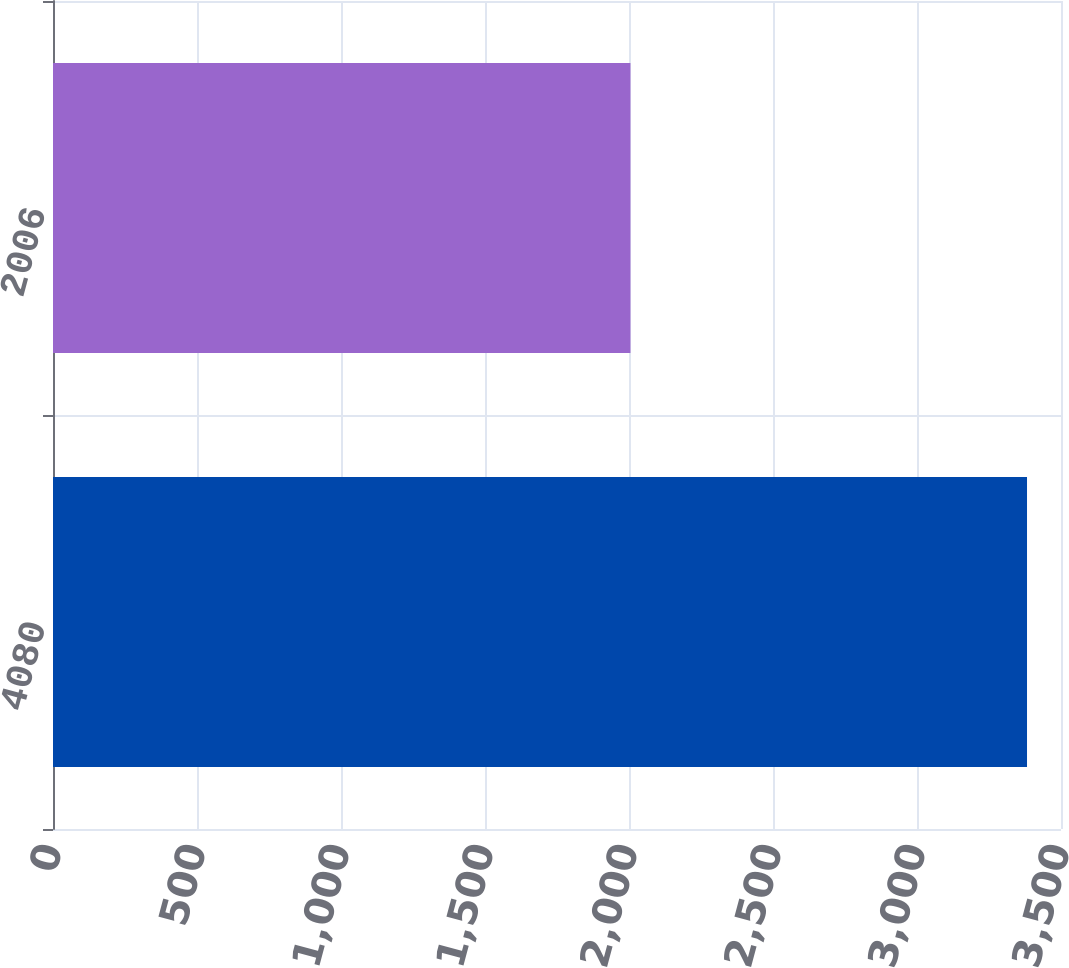Convert chart to OTSL. <chart><loc_0><loc_0><loc_500><loc_500><bar_chart><fcel>4080<fcel>2006<nl><fcel>3382<fcel>2005<nl></chart> 